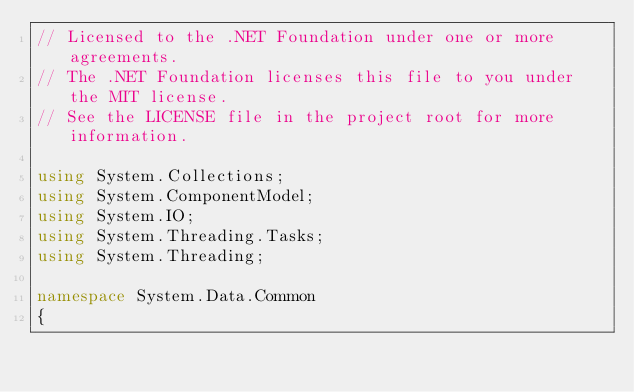Convert code to text. <code><loc_0><loc_0><loc_500><loc_500><_C#_>// Licensed to the .NET Foundation under one or more agreements.
// The .NET Foundation licenses this file to you under the MIT license.
// See the LICENSE file in the project root for more information.

using System.Collections;
using System.ComponentModel;
using System.IO;
using System.Threading.Tasks;
using System.Threading;

namespace System.Data.Common
{</code> 